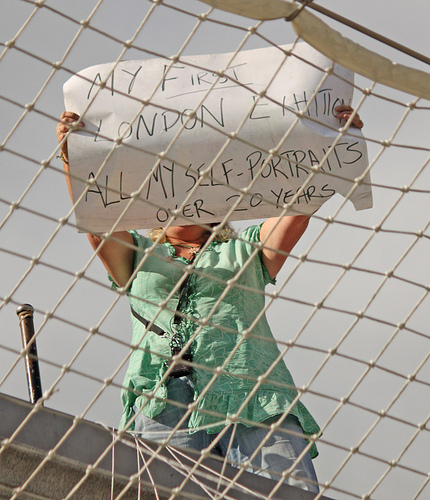<image>
Can you confirm if the sign is next to the fence? No. The sign is not positioned next to the fence. They are located in different areas of the scene. 